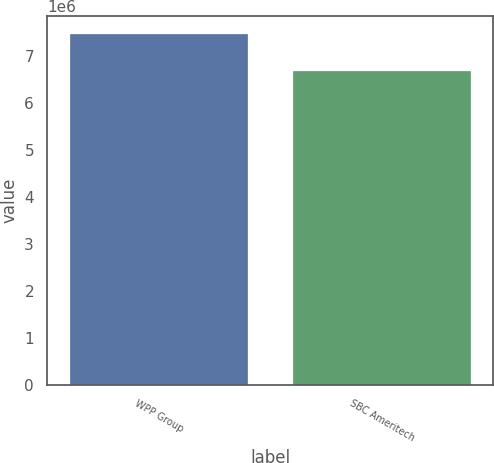<chart> <loc_0><loc_0><loc_500><loc_500><bar_chart><fcel>WPP Group<fcel>SBC Ameritech<nl><fcel>7.463e+06<fcel>6.679e+06<nl></chart> 